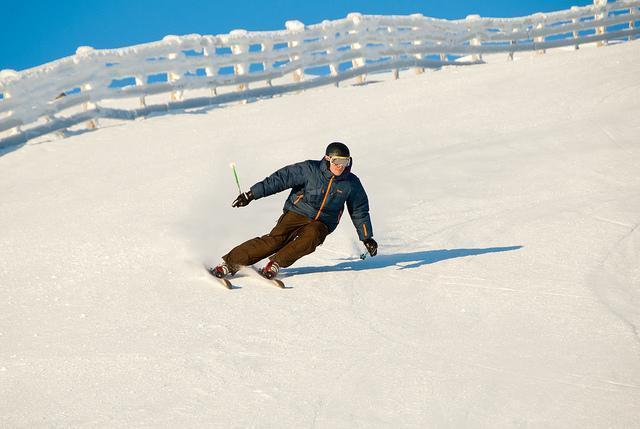How many red frisbees can you see?
Give a very brief answer. 0. 